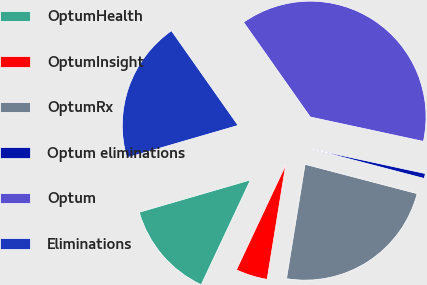Convert chart to OTSL. <chart><loc_0><loc_0><loc_500><loc_500><pie_chart><fcel>OptumHealth<fcel>OptumInsight<fcel>OptumRx<fcel>Optum eliminations<fcel>Optum<fcel>Eliminations<nl><fcel>13.51%<fcel>4.43%<fcel>23.49%<fcel>0.69%<fcel>38.14%<fcel>19.74%<nl></chart> 